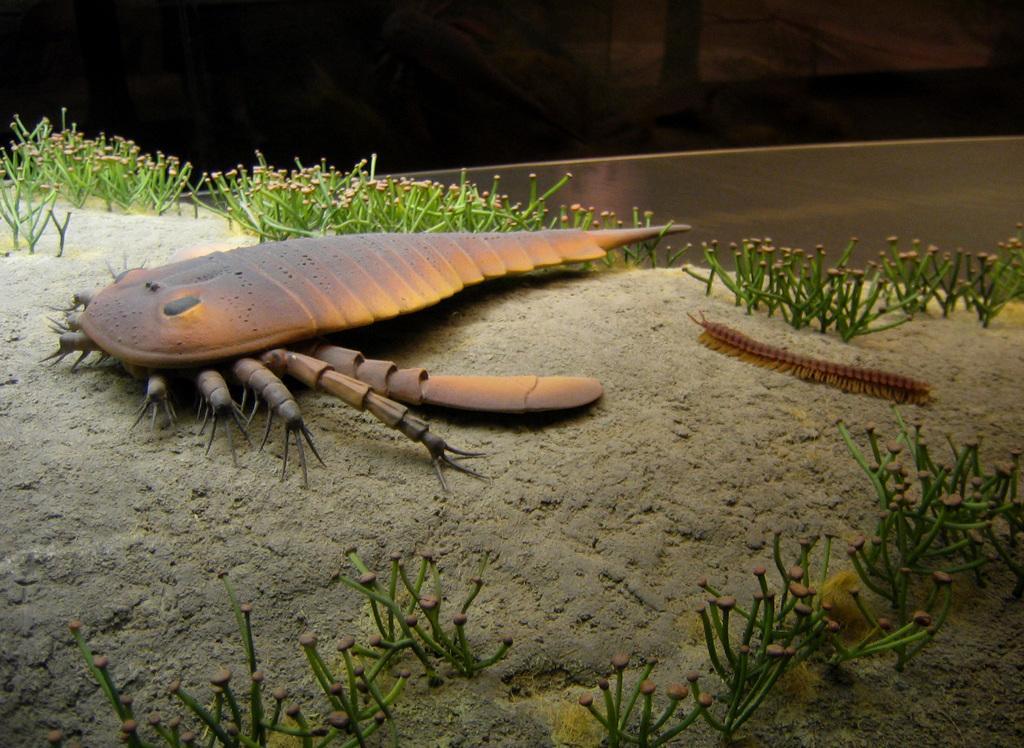In one or two sentences, can you explain what this image depicts? In the front of the image I can see insects and plants. In the background of the image it is dark. 